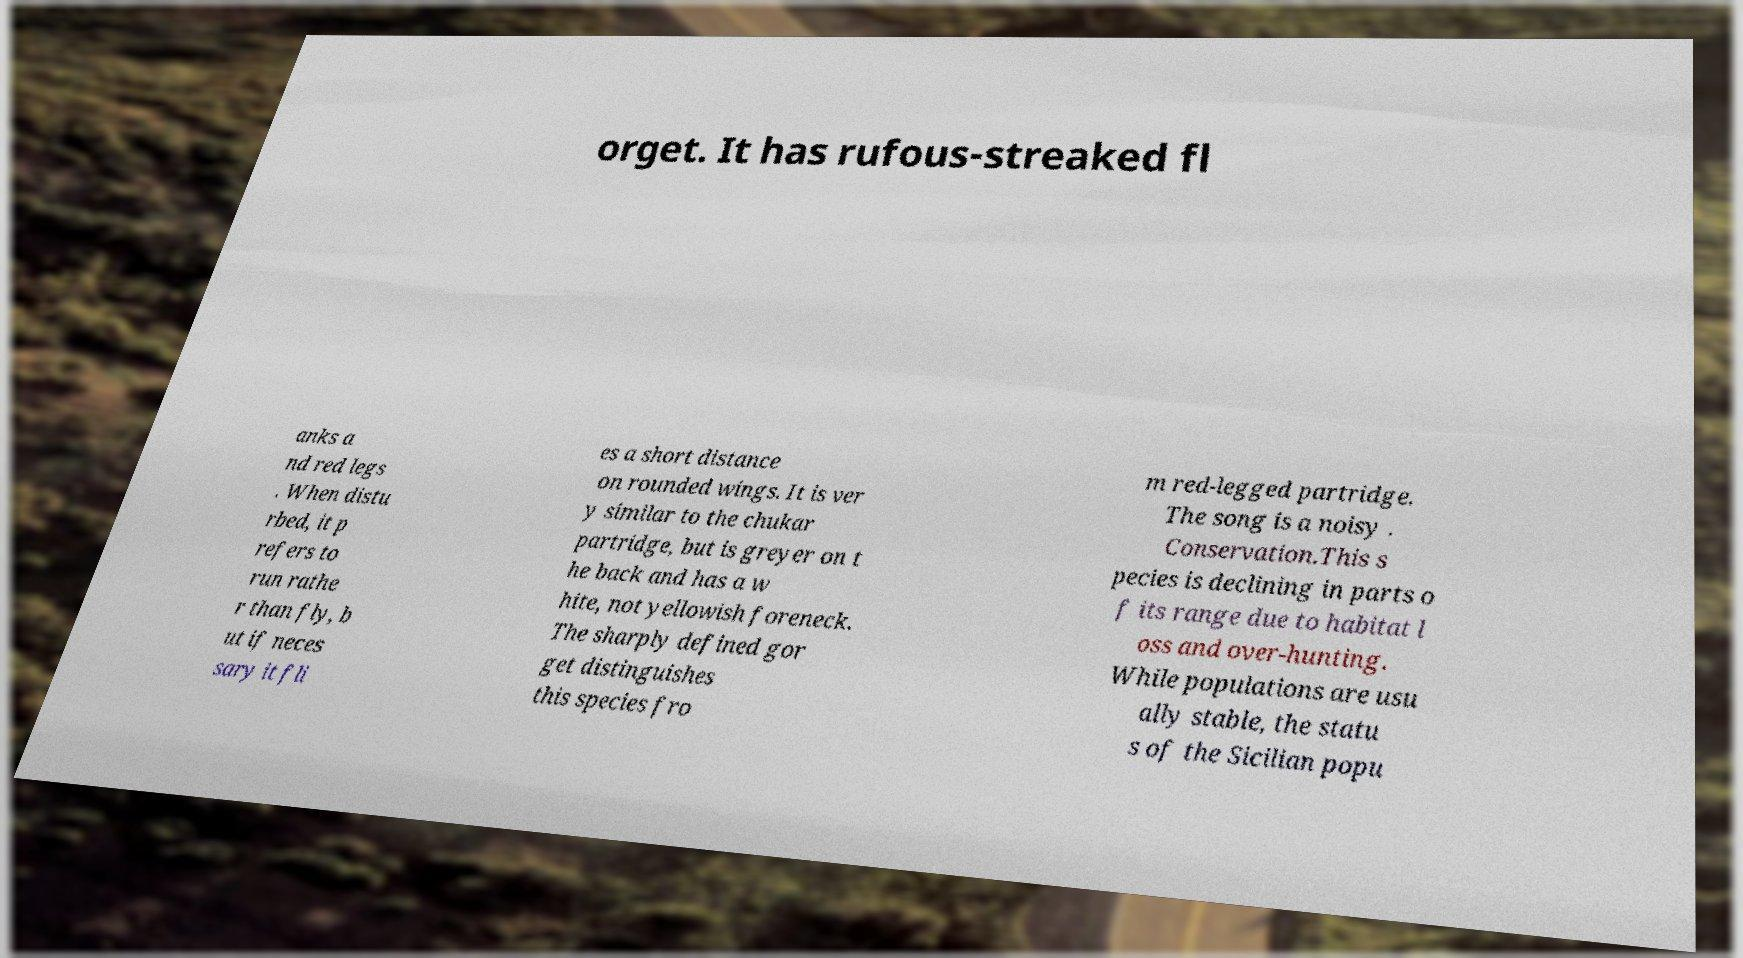Could you extract and type out the text from this image? orget. It has rufous-streaked fl anks a nd red legs . When distu rbed, it p refers to run rathe r than fly, b ut if neces sary it fli es a short distance on rounded wings. It is ver y similar to the chukar partridge, but is greyer on t he back and has a w hite, not yellowish foreneck. The sharply defined gor get distinguishes this species fro m red-legged partridge. The song is a noisy . Conservation.This s pecies is declining in parts o f its range due to habitat l oss and over-hunting. While populations are usu ally stable, the statu s of the Sicilian popu 